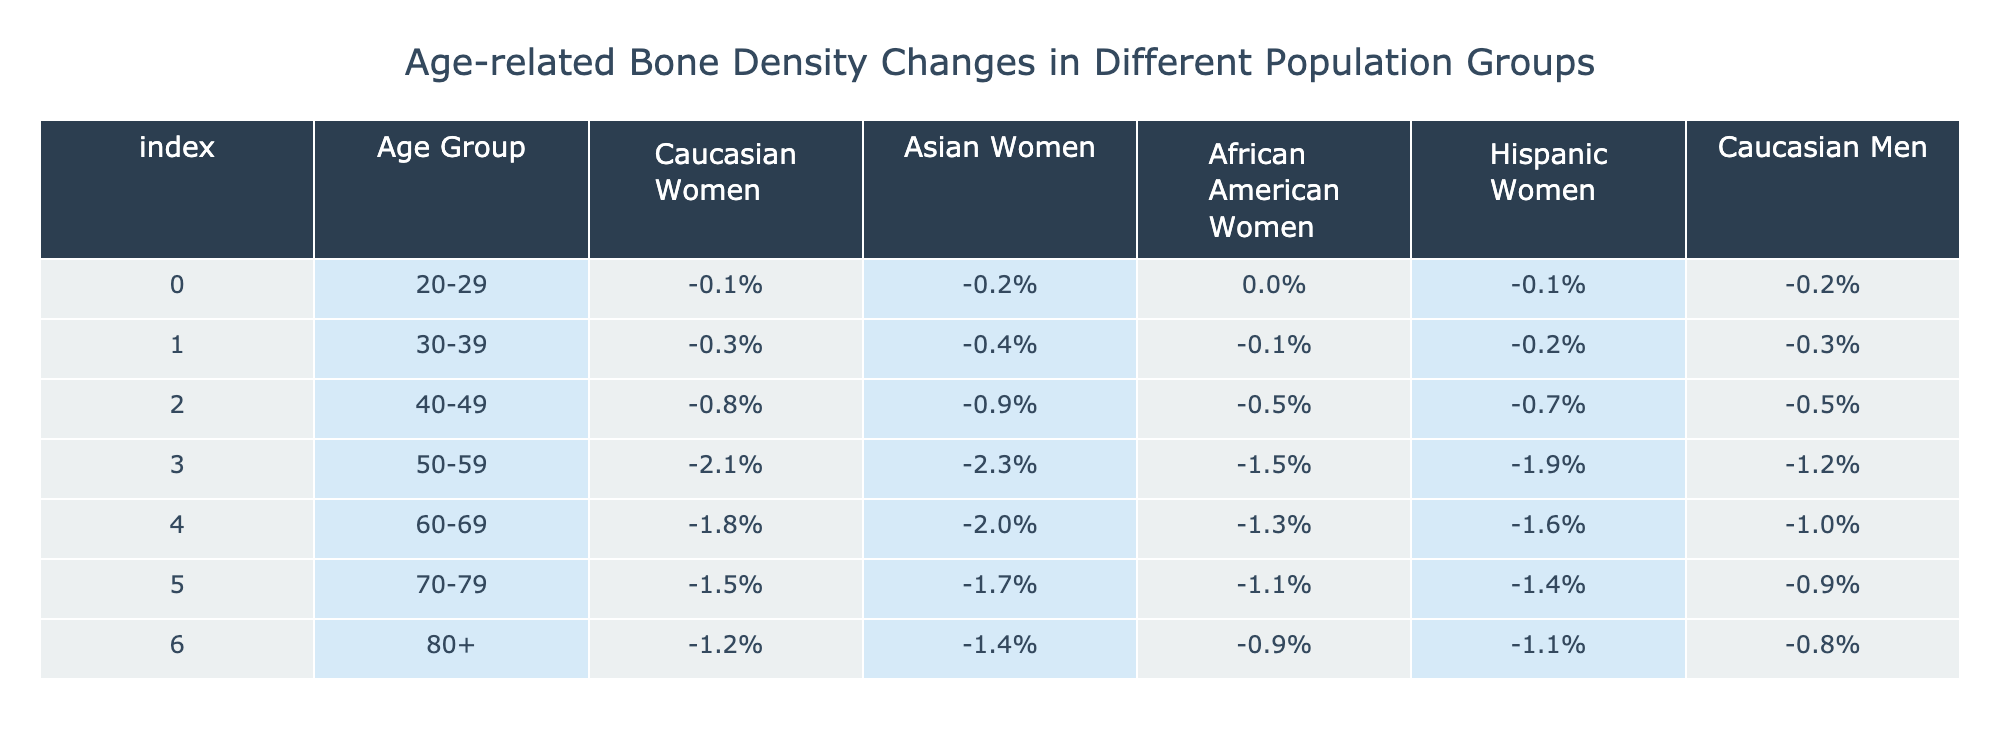What is the bone density change percentage for Caucasian women in the age group 50-59? In the age group 50-59, the bone density change percentage for Caucasian women is listed directly in the table as -2.1%.
Answer: -2.1% Which population group has the least bone density change in the age group 70-79? In the age group 70-79, the bone density change percentages are: Caucasian Women -1.5%, Asian Women -1.7%, African American Women -1.1%, Hispanic Women -1.4%, and Caucasian Men -0.9%. The lowest percentage is for Caucasian Men at -0.9%.
Answer: Caucasian Men What is the average bone density change for African American women across all age groups? The bone density change percentages for African American women are: 0.0% (20-29), -0.1% (30-39), -0.5% (40-49), -1.5% (50-59), -1.3% (60-69), -1.1% (70-79), and -0.9% (80+). Summing these gives a total of -4.4%, and there are 7 age groups. The average is -4.4% / 7 = -0.6286%.
Answer: -0.63% Is the bone density change for Hispanic women higher than for Caucasian men in the age group 60-69? For Hispanic women in the age group 60-69, the percentage is -1.6%, and for Caucasian men, it is -1.0%. Since -1.6% is lower than -1.0%, the statement is false.
Answer: No What is the difference in bone density change between Caucasian women and Asian women in the age group 40-49? The bone density change for Caucasian women in the age group 40-49 is -0.8% and for Asian women, it is -0.9%. The difference is calculated by taking -0.8% - (-0.9%), which equals 0.1%. Caucasian women have a higher bone density change by 0.1%.
Answer: 0.1% 